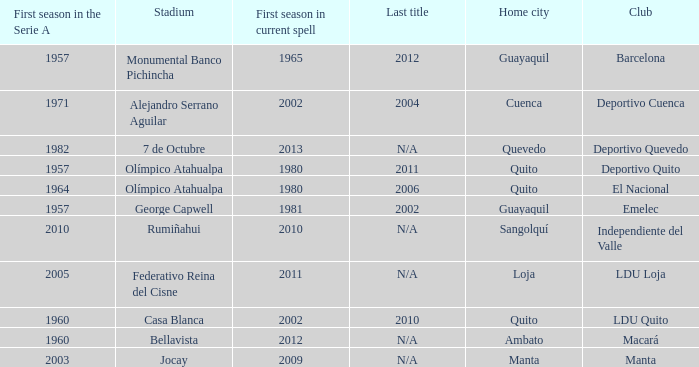Name the last title for 2012 N/A. 